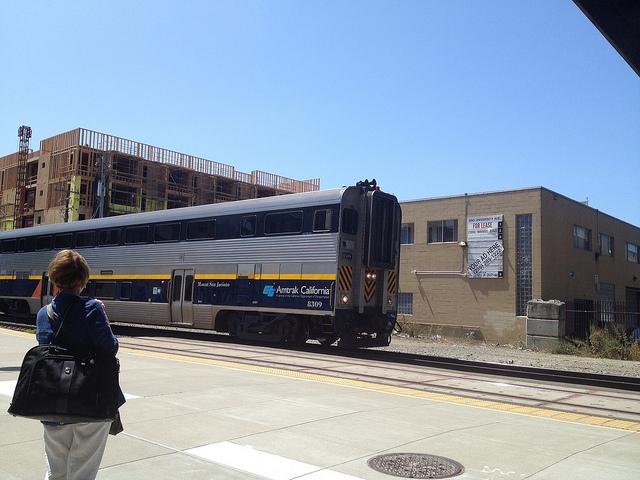How many people are in this photo?
Write a very short answer. 1. What is the purpose of the poster near the person's head?
Be succinct. There is no poster. What color is the woman's bag?
Answer briefly. Black. Is the woman moving silently?
Quick response, please. Yes. What speed is the train moving at?
Write a very short answer. Slow. Is this picture in color?
Short answer required. Yes. Is the person a boy or girl?
Keep it brief. Girl. What color is the stripe on the train?
Quick response, please. Yellow. Where is the white line?
Be succinct. On sidewalk. On what side of the man is the sun?
Keep it brief. Right. 